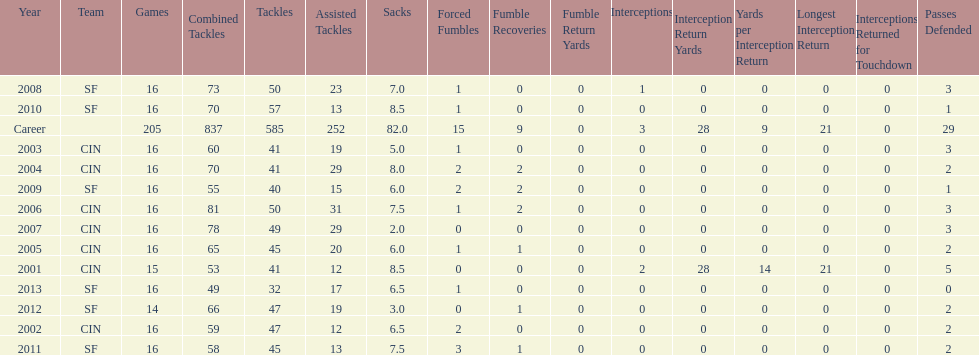How many years did he play without recovering a fumble? 7. 